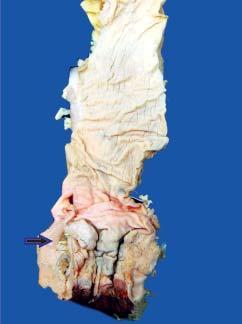what does the anorectal margin show?
Answer the question using a single word or phrase. An ulcerated mucosa with thickened wall 